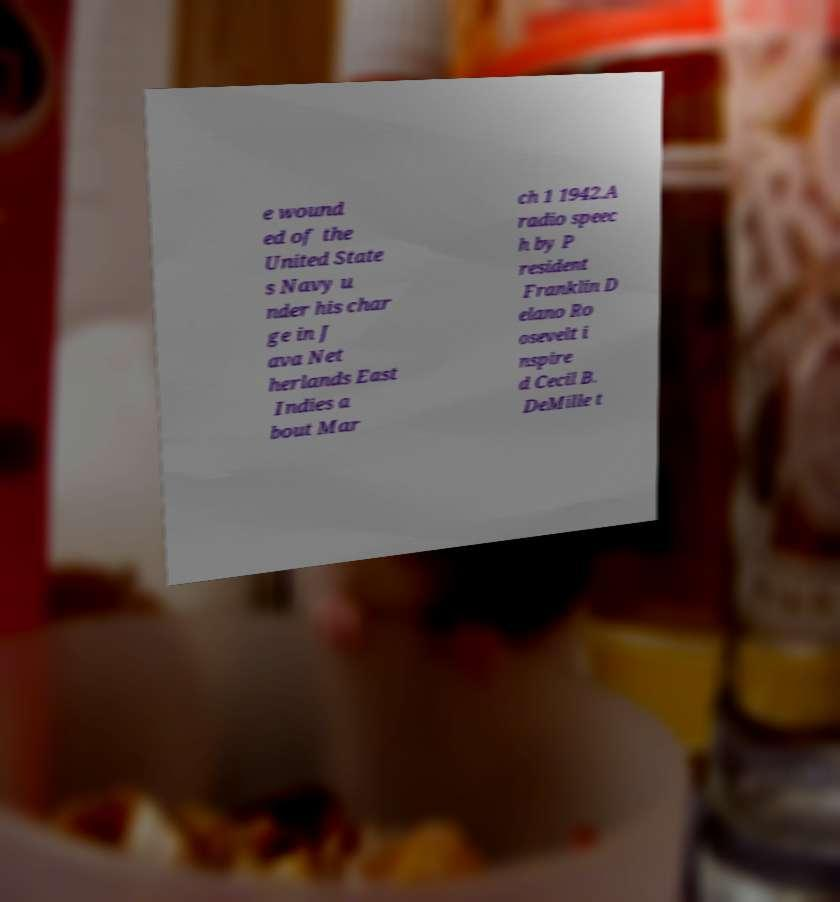Could you extract and type out the text from this image? e wound ed of the United State s Navy u nder his char ge in J ava Net herlands East Indies a bout Mar ch 1 1942.A radio speec h by P resident Franklin D elano Ro osevelt i nspire d Cecil B. DeMille t 